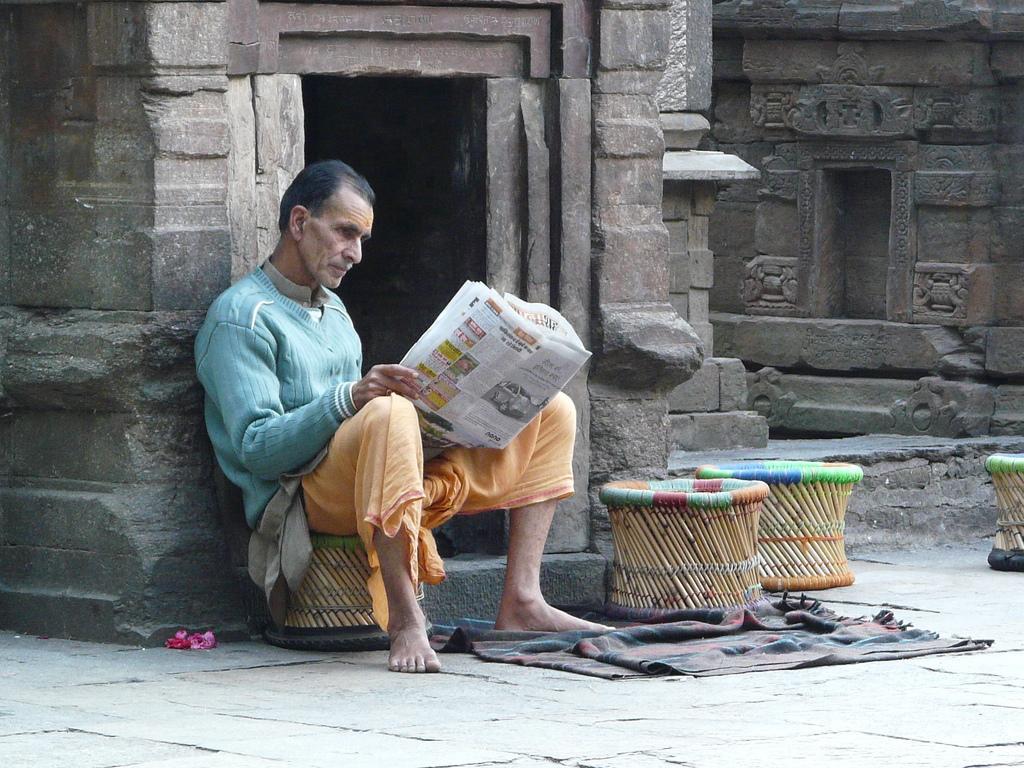Describe this image in one or two sentences. In the center of the image we can see a man sitting and holding a newspaper in his hand. There are stools. In the background we can see a building. At the bottom there is a blanket. 